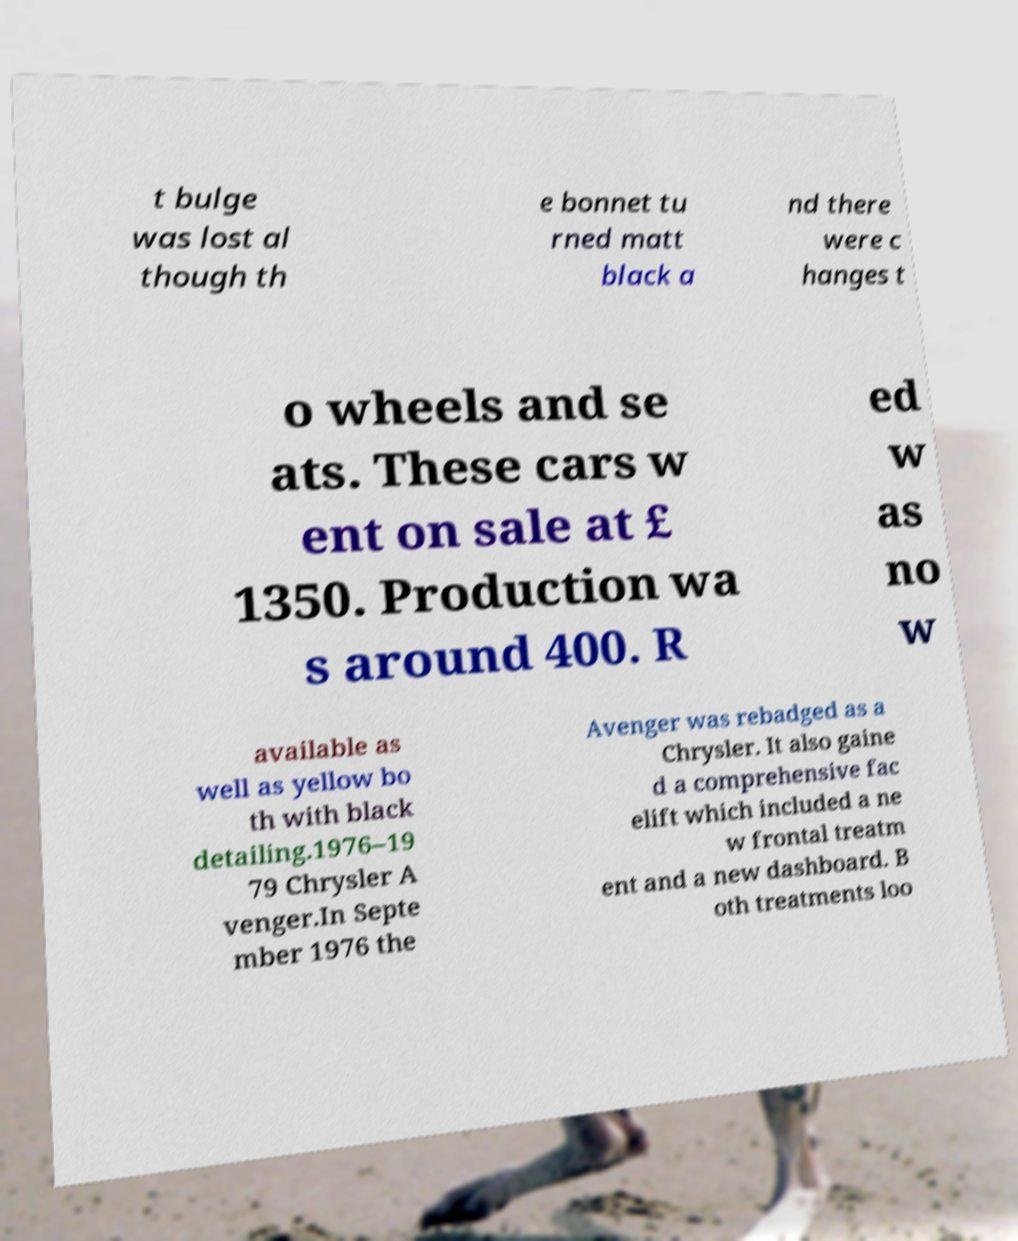There's text embedded in this image that I need extracted. Can you transcribe it verbatim? t bulge was lost al though th e bonnet tu rned matt black a nd there were c hanges t o wheels and se ats. These cars w ent on sale at £ 1350. Production wa s around 400. R ed w as no w available as well as yellow bo th with black detailing.1976–19 79 Chrysler A venger.In Septe mber 1976 the Avenger was rebadged as a Chrysler. It also gaine d a comprehensive fac elift which included a ne w frontal treatm ent and a new dashboard. B oth treatments loo 